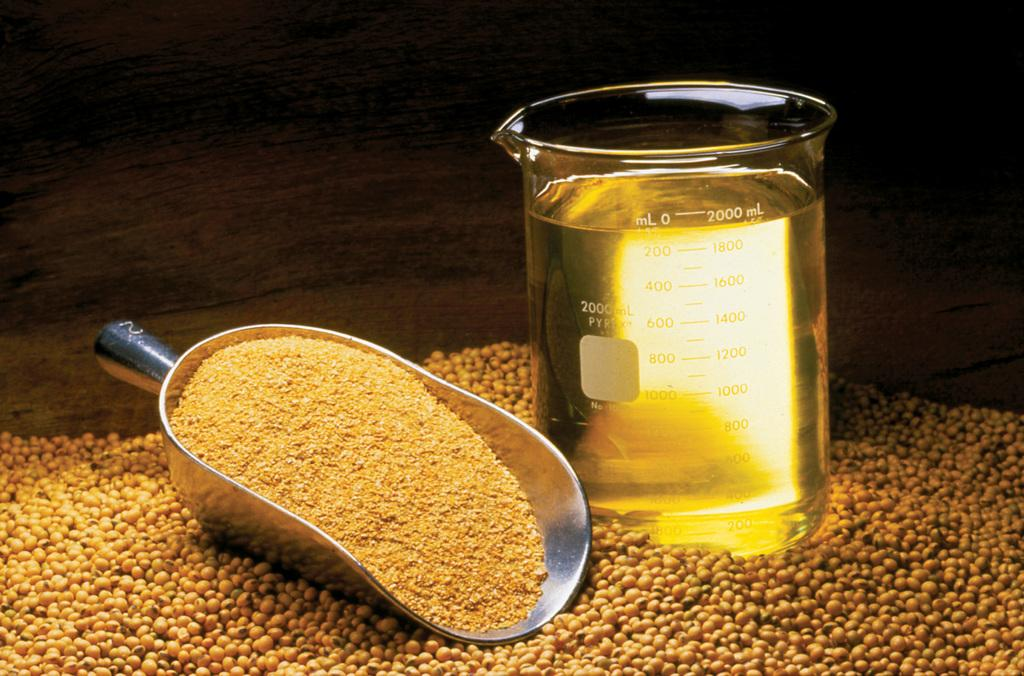Provide a one-sentence caption for the provided image. A scooper is next to a measuring glass that is 2000 ml full of liquid. 